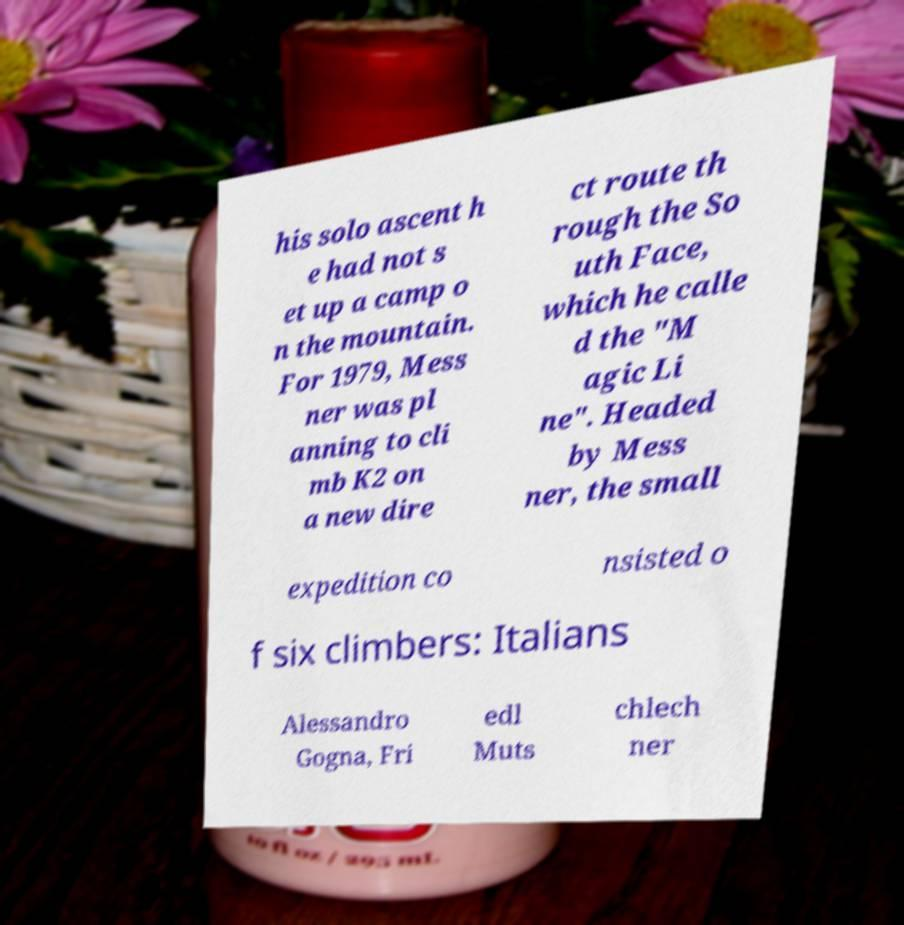Could you extract and type out the text from this image? his solo ascent h e had not s et up a camp o n the mountain. For 1979, Mess ner was pl anning to cli mb K2 on a new dire ct route th rough the So uth Face, which he calle d the "M agic Li ne". Headed by Mess ner, the small expedition co nsisted o f six climbers: Italians Alessandro Gogna, Fri edl Muts chlech ner 